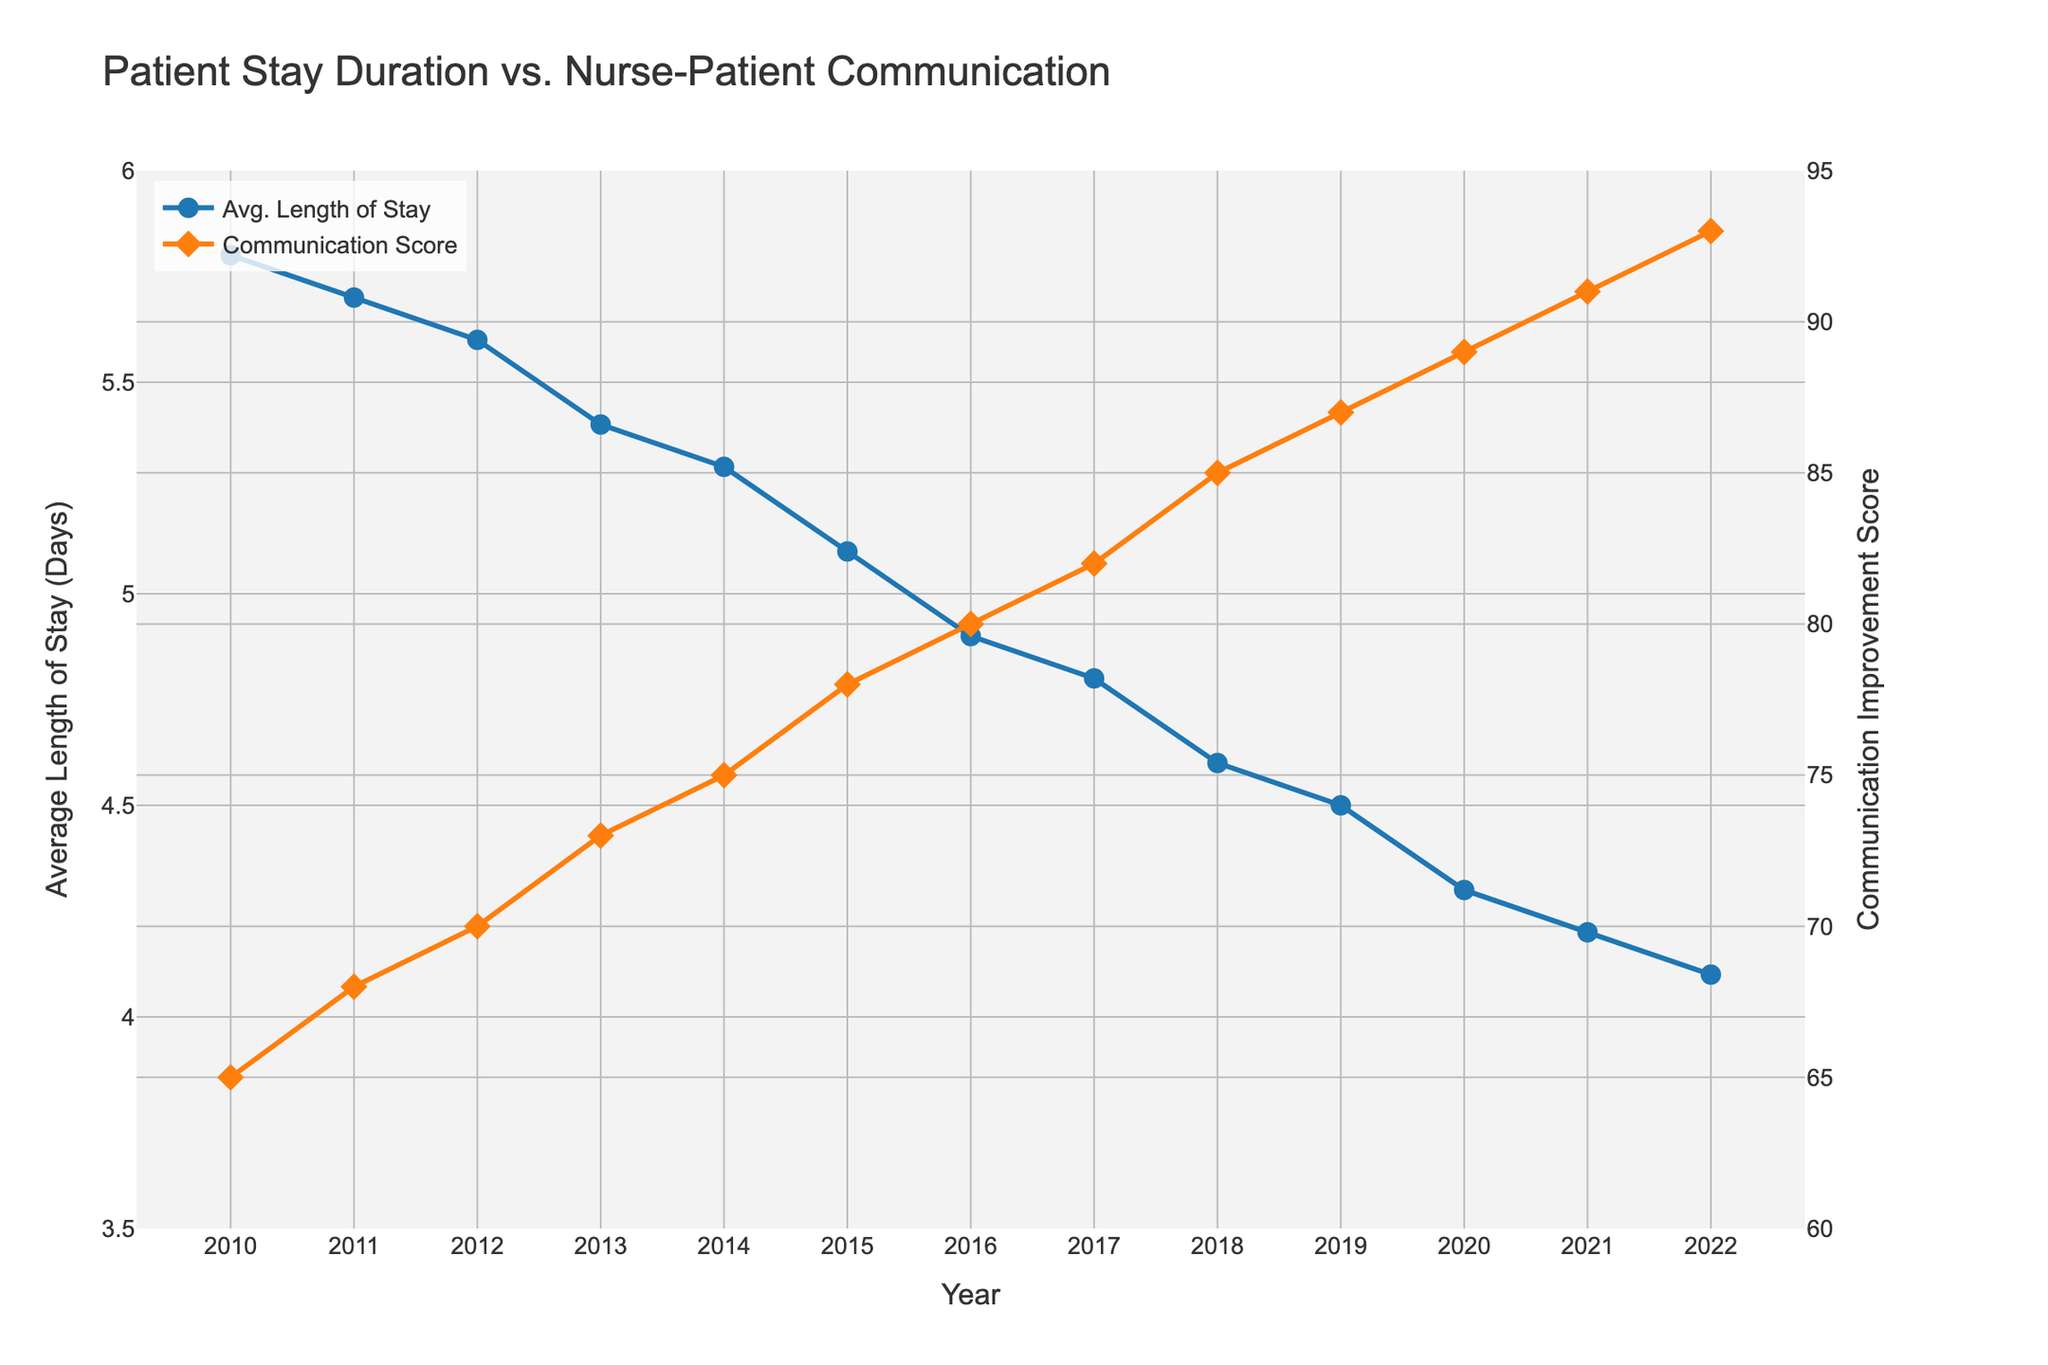What's the average of the average length of stay for the years 2010-2012? To find the average, sum the average lengths of stay for 2010, 2011, and 2012, then divide by 3. (5.8 + 5.7 + 5.6) = 17.1, so 17.1 / 3 = 5.7
Answer: 5.7 Which year saw the greatest improvement in communication score compared to the previous year? To identify this, calculate the yearly differences for the communication improvement scores and find the maximum: 68-65=3, 70-68=2, 73-70=3, 75-73=2, 78-75=3, 80-78=2, 82-80=2, 85-82=3, 87-85=2, 89-87=2, 91-89=2, 93-91=2. The greatest improvement was 3, seen in 2011, 2013, 2015, and 2018
Answer: 2011, 2013, 2015, 2018 Does the average length of stay (Days) decrease each year? Verify if each subsequent year has a lower value than the previous: 5.8 > 5.7 > 5.6 > 5.4 > 5.3 > 5.1 > 4.9 > 4.8 > 4.6 > 4.5 > 4.3 > 4.2 > 4.1; All values decrease consistently year by year
Answer: Yes In which year did the average length of stay first drop below 5 days? Locate the first year in the figure where the average length of stay is less than 5 days. This first occurs in 2016
Answer: 2016 By how much did the average length of stay decrease from 2010 to 2022? Calculate the difference between the average length of stay in 2010 and 2022: 5.8 - 4.1 = 1.7
Answer: 1.7 How are the visual attributes of the communication score and average length of stay lines different? Note that the average length of stay line is blue with circle markers, and the communication score line is orange with diamond markers
Answer: Blue circles vs. orange diamonds What's the communication improvement score when the average length of stay is 5.1 days? According to the figure, in 2015, the average length of stay is 5.1 days and the corresponding communication improvement score is 78
Answer: 78 What is the average communication improvement score for the years 2020-2022? Sum the communication improvement scores for 2020, 2021, and 2022, then divide by 3. (89 + 91 + 93) = 273, so 273 / 3 = 91
Answer: 91 What was the last year that had a communication improvement score below 80? The figure indicates that in 2015 the communication improvement score was 78, and it crossed 80 in 2016
Answer: 2015 